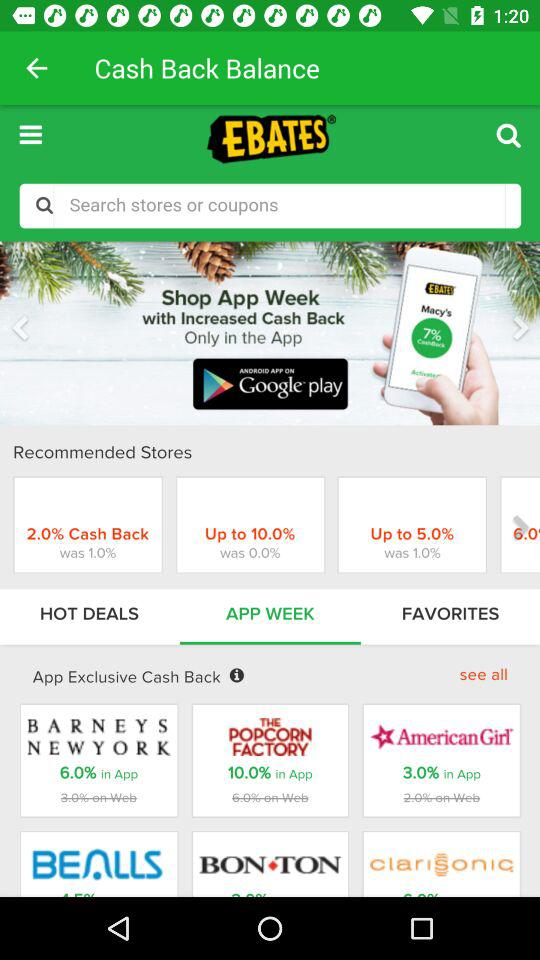How much exclusive cashback is in the "BARNEYS NEW YORK" app? There is 6% exclusive cashback in the "BARNEYS NEW YORK" app. 